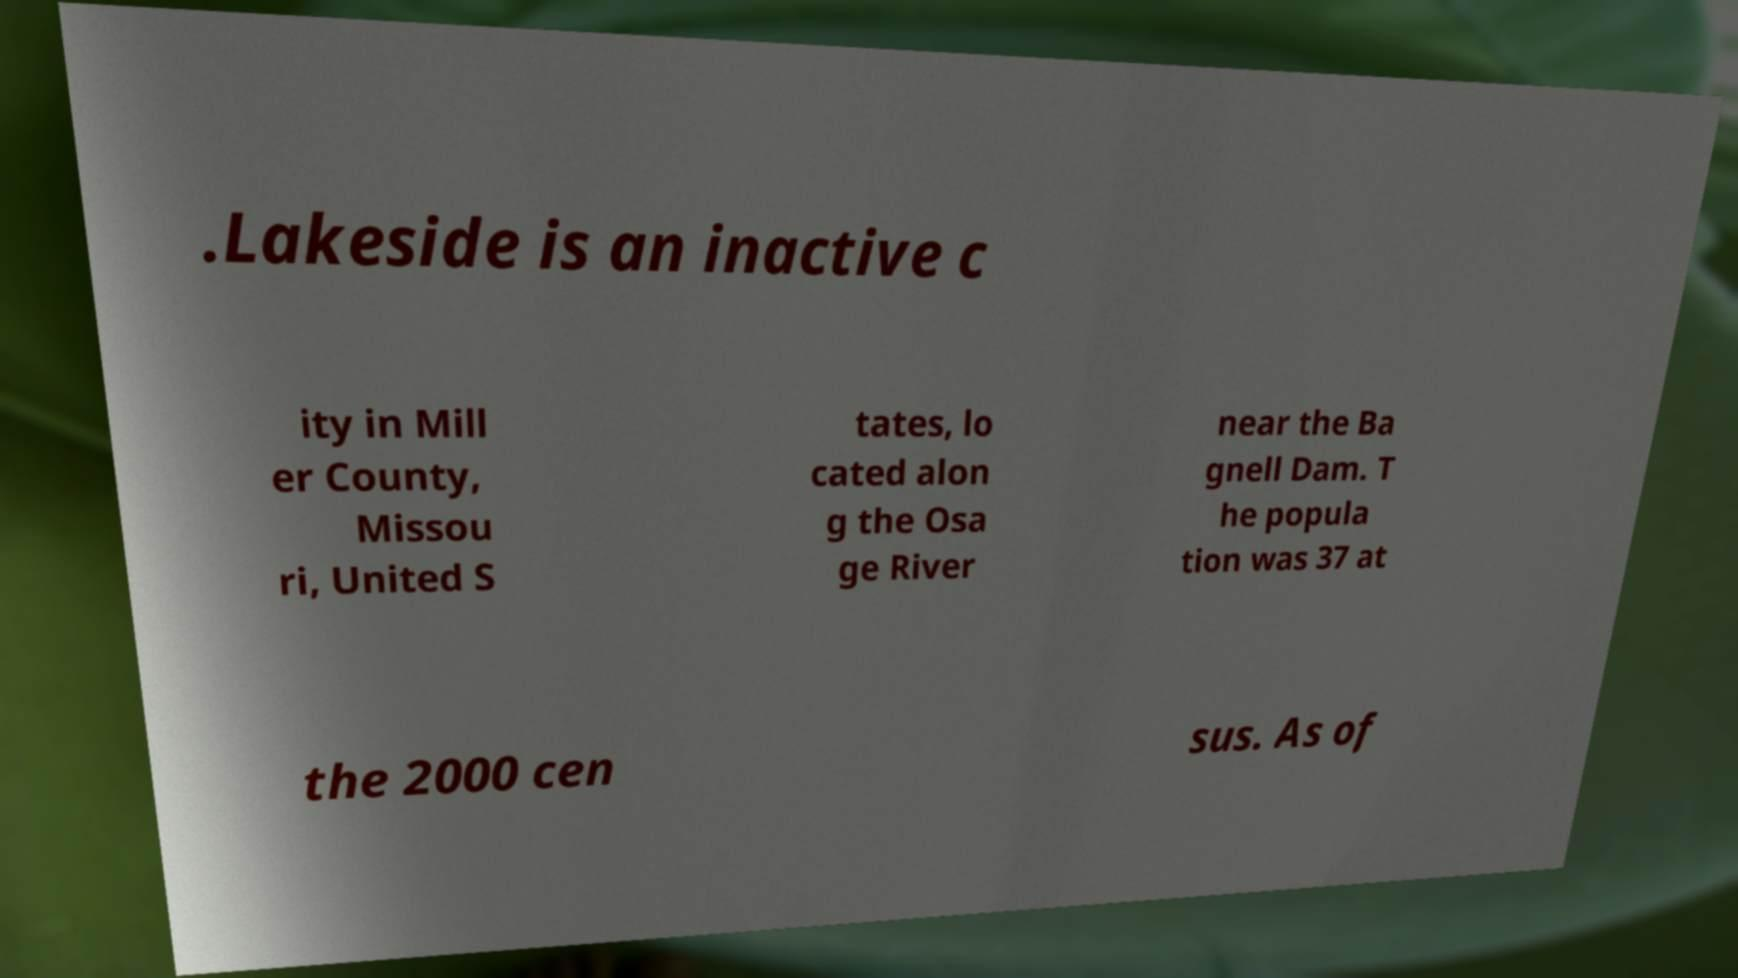Please identify and transcribe the text found in this image. .Lakeside is an inactive c ity in Mill er County, Missou ri, United S tates, lo cated alon g the Osa ge River near the Ba gnell Dam. T he popula tion was 37 at the 2000 cen sus. As of 